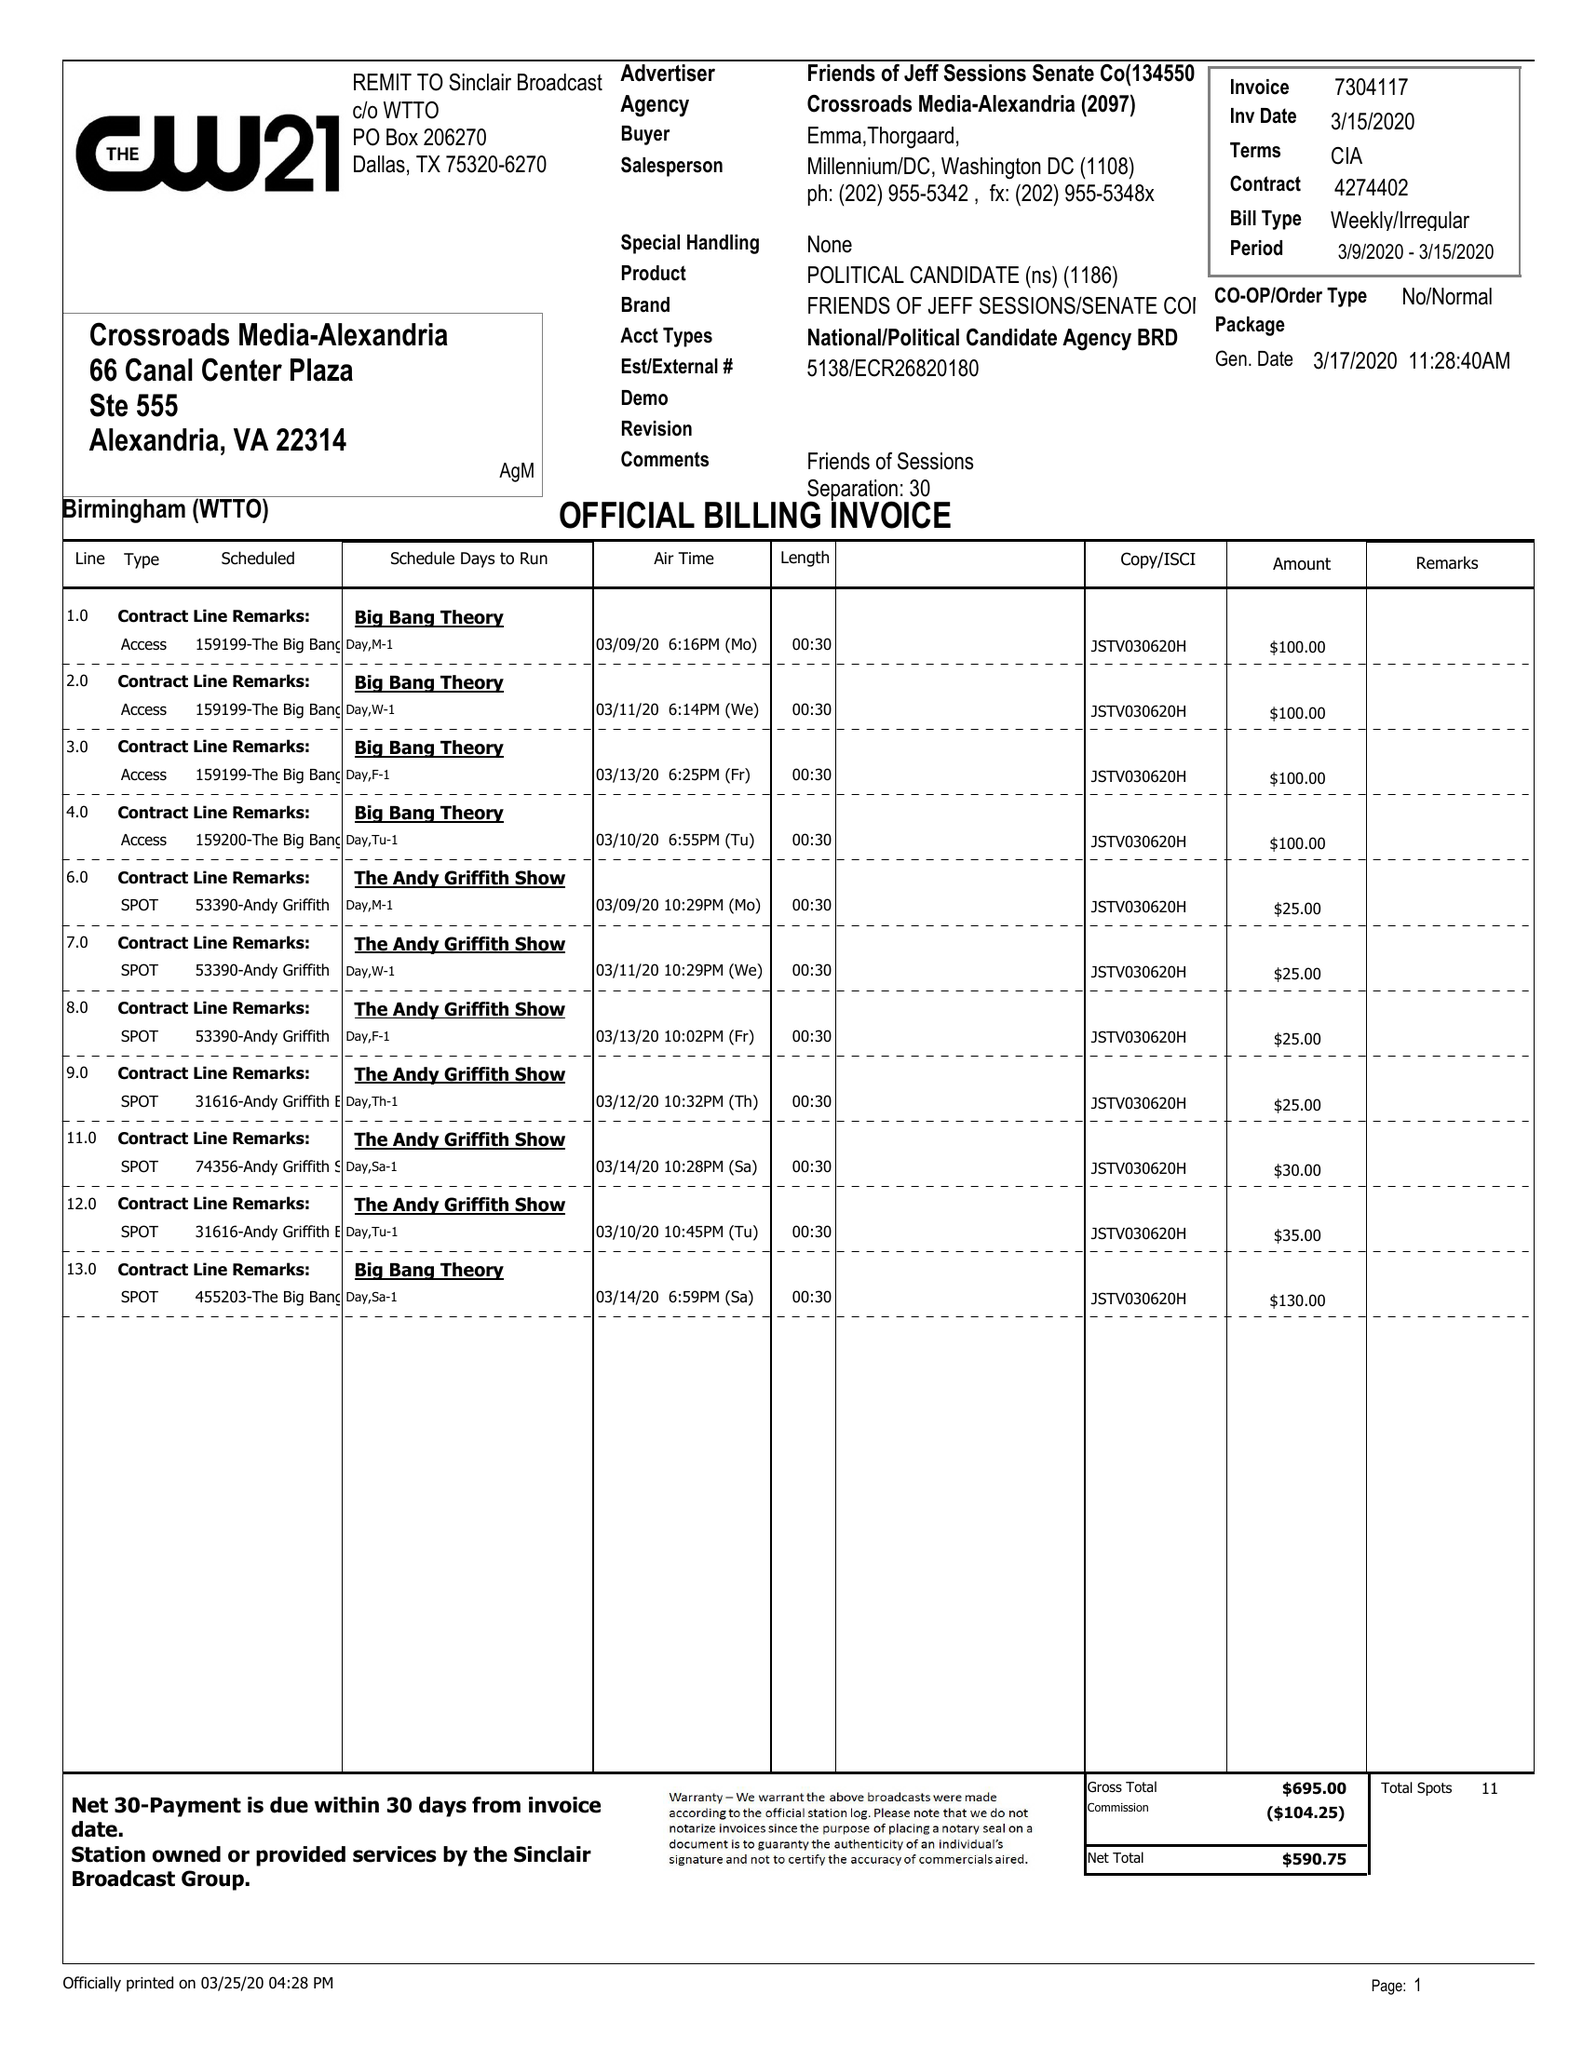What is the value for the gross_amount?
Answer the question using a single word or phrase. 695.00 